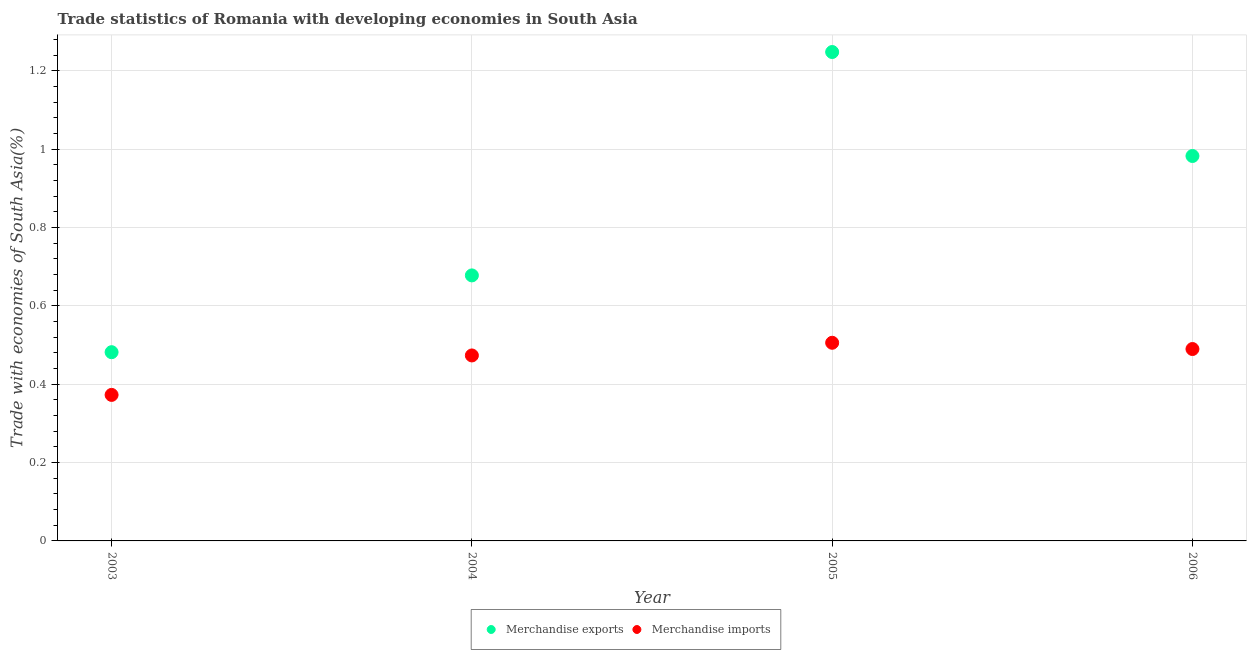Is the number of dotlines equal to the number of legend labels?
Keep it short and to the point. Yes. What is the merchandise imports in 2004?
Offer a very short reply. 0.47. Across all years, what is the maximum merchandise imports?
Give a very brief answer. 0.51. Across all years, what is the minimum merchandise imports?
Give a very brief answer. 0.37. In which year was the merchandise exports maximum?
Keep it short and to the point. 2005. What is the total merchandise exports in the graph?
Your response must be concise. 3.39. What is the difference between the merchandise exports in 2003 and that in 2004?
Offer a terse response. -0.2. What is the difference between the merchandise imports in 2003 and the merchandise exports in 2006?
Your response must be concise. -0.61. What is the average merchandise imports per year?
Your answer should be very brief. 0.46. In the year 2004, what is the difference between the merchandise exports and merchandise imports?
Your answer should be very brief. 0.2. In how many years, is the merchandise exports greater than 0.52 %?
Provide a succinct answer. 3. What is the ratio of the merchandise imports in 2003 to that in 2004?
Give a very brief answer. 0.79. What is the difference between the highest and the second highest merchandise imports?
Keep it short and to the point. 0.02. What is the difference between the highest and the lowest merchandise exports?
Provide a short and direct response. 0.77. Is the sum of the merchandise imports in 2003 and 2005 greater than the maximum merchandise exports across all years?
Your answer should be very brief. No. Is the merchandise exports strictly greater than the merchandise imports over the years?
Ensure brevity in your answer.  Yes. Is the merchandise imports strictly less than the merchandise exports over the years?
Your response must be concise. Yes. How many years are there in the graph?
Keep it short and to the point. 4. Are the values on the major ticks of Y-axis written in scientific E-notation?
Your response must be concise. No. Does the graph contain grids?
Keep it short and to the point. Yes. Where does the legend appear in the graph?
Your answer should be compact. Bottom center. How many legend labels are there?
Offer a very short reply. 2. How are the legend labels stacked?
Provide a short and direct response. Horizontal. What is the title of the graph?
Offer a very short reply. Trade statistics of Romania with developing economies in South Asia. Does "Public credit registry" appear as one of the legend labels in the graph?
Ensure brevity in your answer.  No. What is the label or title of the Y-axis?
Provide a succinct answer. Trade with economies of South Asia(%). What is the Trade with economies of South Asia(%) in Merchandise exports in 2003?
Your answer should be very brief. 0.48. What is the Trade with economies of South Asia(%) in Merchandise imports in 2003?
Offer a very short reply. 0.37. What is the Trade with economies of South Asia(%) in Merchandise exports in 2004?
Keep it short and to the point. 0.68. What is the Trade with economies of South Asia(%) in Merchandise imports in 2004?
Your response must be concise. 0.47. What is the Trade with economies of South Asia(%) in Merchandise exports in 2005?
Your answer should be very brief. 1.25. What is the Trade with economies of South Asia(%) in Merchandise imports in 2005?
Offer a very short reply. 0.51. What is the Trade with economies of South Asia(%) of Merchandise exports in 2006?
Make the answer very short. 0.98. What is the Trade with economies of South Asia(%) of Merchandise imports in 2006?
Offer a very short reply. 0.49. Across all years, what is the maximum Trade with economies of South Asia(%) in Merchandise exports?
Give a very brief answer. 1.25. Across all years, what is the maximum Trade with economies of South Asia(%) of Merchandise imports?
Keep it short and to the point. 0.51. Across all years, what is the minimum Trade with economies of South Asia(%) in Merchandise exports?
Ensure brevity in your answer.  0.48. Across all years, what is the minimum Trade with economies of South Asia(%) in Merchandise imports?
Provide a succinct answer. 0.37. What is the total Trade with economies of South Asia(%) in Merchandise exports in the graph?
Ensure brevity in your answer.  3.39. What is the total Trade with economies of South Asia(%) in Merchandise imports in the graph?
Give a very brief answer. 1.84. What is the difference between the Trade with economies of South Asia(%) in Merchandise exports in 2003 and that in 2004?
Ensure brevity in your answer.  -0.2. What is the difference between the Trade with economies of South Asia(%) of Merchandise imports in 2003 and that in 2004?
Your answer should be compact. -0.1. What is the difference between the Trade with economies of South Asia(%) in Merchandise exports in 2003 and that in 2005?
Offer a terse response. -0.77. What is the difference between the Trade with economies of South Asia(%) in Merchandise imports in 2003 and that in 2005?
Keep it short and to the point. -0.13. What is the difference between the Trade with economies of South Asia(%) in Merchandise exports in 2003 and that in 2006?
Offer a very short reply. -0.5. What is the difference between the Trade with economies of South Asia(%) of Merchandise imports in 2003 and that in 2006?
Offer a very short reply. -0.12. What is the difference between the Trade with economies of South Asia(%) in Merchandise exports in 2004 and that in 2005?
Your response must be concise. -0.57. What is the difference between the Trade with economies of South Asia(%) of Merchandise imports in 2004 and that in 2005?
Provide a short and direct response. -0.03. What is the difference between the Trade with economies of South Asia(%) of Merchandise exports in 2004 and that in 2006?
Provide a succinct answer. -0.3. What is the difference between the Trade with economies of South Asia(%) in Merchandise imports in 2004 and that in 2006?
Provide a succinct answer. -0.02. What is the difference between the Trade with economies of South Asia(%) of Merchandise exports in 2005 and that in 2006?
Give a very brief answer. 0.27. What is the difference between the Trade with economies of South Asia(%) of Merchandise imports in 2005 and that in 2006?
Ensure brevity in your answer.  0.02. What is the difference between the Trade with economies of South Asia(%) in Merchandise exports in 2003 and the Trade with economies of South Asia(%) in Merchandise imports in 2004?
Your response must be concise. 0.01. What is the difference between the Trade with economies of South Asia(%) in Merchandise exports in 2003 and the Trade with economies of South Asia(%) in Merchandise imports in 2005?
Ensure brevity in your answer.  -0.02. What is the difference between the Trade with economies of South Asia(%) in Merchandise exports in 2003 and the Trade with economies of South Asia(%) in Merchandise imports in 2006?
Make the answer very short. -0.01. What is the difference between the Trade with economies of South Asia(%) in Merchandise exports in 2004 and the Trade with economies of South Asia(%) in Merchandise imports in 2005?
Provide a succinct answer. 0.17. What is the difference between the Trade with economies of South Asia(%) of Merchandise exports in 2004 and the Trade with economies of South Asia(%) of Merchandise imports in 2006?
Offer a very short reply. 0.19. What is the difference between the Trade with economies of South Asia(%) of Merchandise exports in 2005 and the Trade with economies of South Asia(%) of Merchandise imports in 2006?
Offer a very short reply. 0.76. What is the average Trade with economies of South Asia(%) in Merchandise exports per year?
Provide a succinct answer. 0.85. What is the average Trade with economies of South Asia(%) of Merchandise imports per year?
Your response must be concise. 0.46. In the year 2003, what is the difference between the Trade with economies of South Asia(%) of Merchandise exports and Trade with economies of South Asia(%) of Merchandise imports?
Keep it short and to the point. 0.11. In the year 2004, what is the difference between the Trade with economies of South Asia(%) of Merchandise exports and Trade with economies of South Asia(%) of Merchandise imports?
Provide a short and direct response. 0.2. In the year 2005, what is the difference between the Trade with economies of South Asia(%) in Merchandise exports and Trade with economies of South Asia(%) in Merchandise imports?
Provide a succinct answer. 0.74. In the year 2006, what is the difference between the Trade with economies of South Asia(%) in Merchandise exports and Trade with economies of South Asia(%) in Merchandise imports?
Offer a terse response. 0.49. What is the ratio of the Trade with economies of South Asia(%) of Merchandise exports in 2003 to that in 2004?
Your response must be concise. 0.71. What is the ratio of the Trade with economies of South Asia(%) in Merchandise imports in 2003 to that in 2004?
Your answer should be very brief. 0.79. What is the ratio of the Trade with economies of South Asia(%) in Merchandise exports in 2003 to that in 2005?
Ensure brevity in your answer.  0.39. What is the ratio of the Trade with economies of South Asia(%) in Merchandise imports in 2003 to that in 2005?
Keep it short and to the point. 0.74. What is the ratio of the Trade with economies of South Asia(%) of Merchandise exports in 2003 to that in 2006?
Provide a succinct answer. 0.49. What is the ratio of the Trade with economies of South Asia(%) of Merchandise imports in 2003 to that in 2006?
Keep it short and to the point. 0.76. What is the ratio of the Trade with economies of South Asia(%) in Merchandise exports in 2004 to that in 2005?
Ensure brevity in your answer.  0.54. What is the ratio of the Trade with economies of South Asia(%) of Merchandise imports in 2004 to that in 2005?
Ensure brevity in your answer.  0.94. What is the ratio of the Trade with economies of South Asia(%) in Merchandise exports in 2004 to that in 2006?
Offer a terse response. 0.69. What is the ratio of the Trade with economies of South Asia(%) in Merchandise imports in 2004 to that in 2006?
Make the answer very short. 0.97. What is the ratio of the Trade with economies of South Asia(%) in Merchandise exports in 2005 to that in 2006?
Provide a short and direct response. 1.27. What is the ratio of the Trade with economies of South Asia(%) of Merchandise imports in 2005 to that in 2006?
Provide a succinct answer. 1.03. What is the difference between the highest and the second highest Trade with economies of South Asia(%) in Merchandise exports?
Provide a succinct answer. 0.27. What is the difference between the highest and the second highest Trade with economies of South Asia(%) in Merchandise imports?
Give a very brief answer. 0.02. What is the difference between the highest and the lowest Trade with economies of South Asia(%) in Merchandise exports?
Offer a terse response. 0.77. What is the difference between the highest and the lowest Trade with economies of South Asia(%) in Merchandise imports?
Your response must be concise. 0.13. 